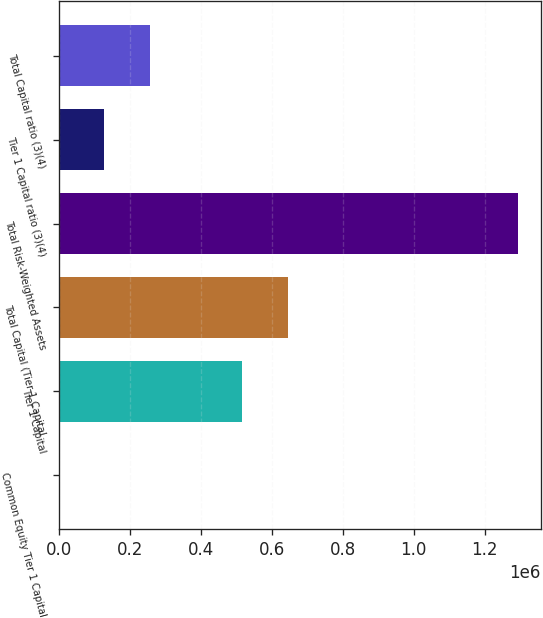Convert chart. <chart><loc_0><loc_0><loc_500><loc_500><bar_chart><fcel>Common Equity Tier 1 Capital<fcel>Tier 1 Capital<fcel>Total Capital (Tier 1 Capital<fcel>Total Risk-Weighted Assets<fcel>Tier 1 Capital ratio (3)(4)<fcel>Total Capital ratio (3)(4)<nl><fcel>10.57<fcel>517048<fcel>646308<fcel>1.2926e+06<fcel>129270<fcel>258529<nl></chart> 